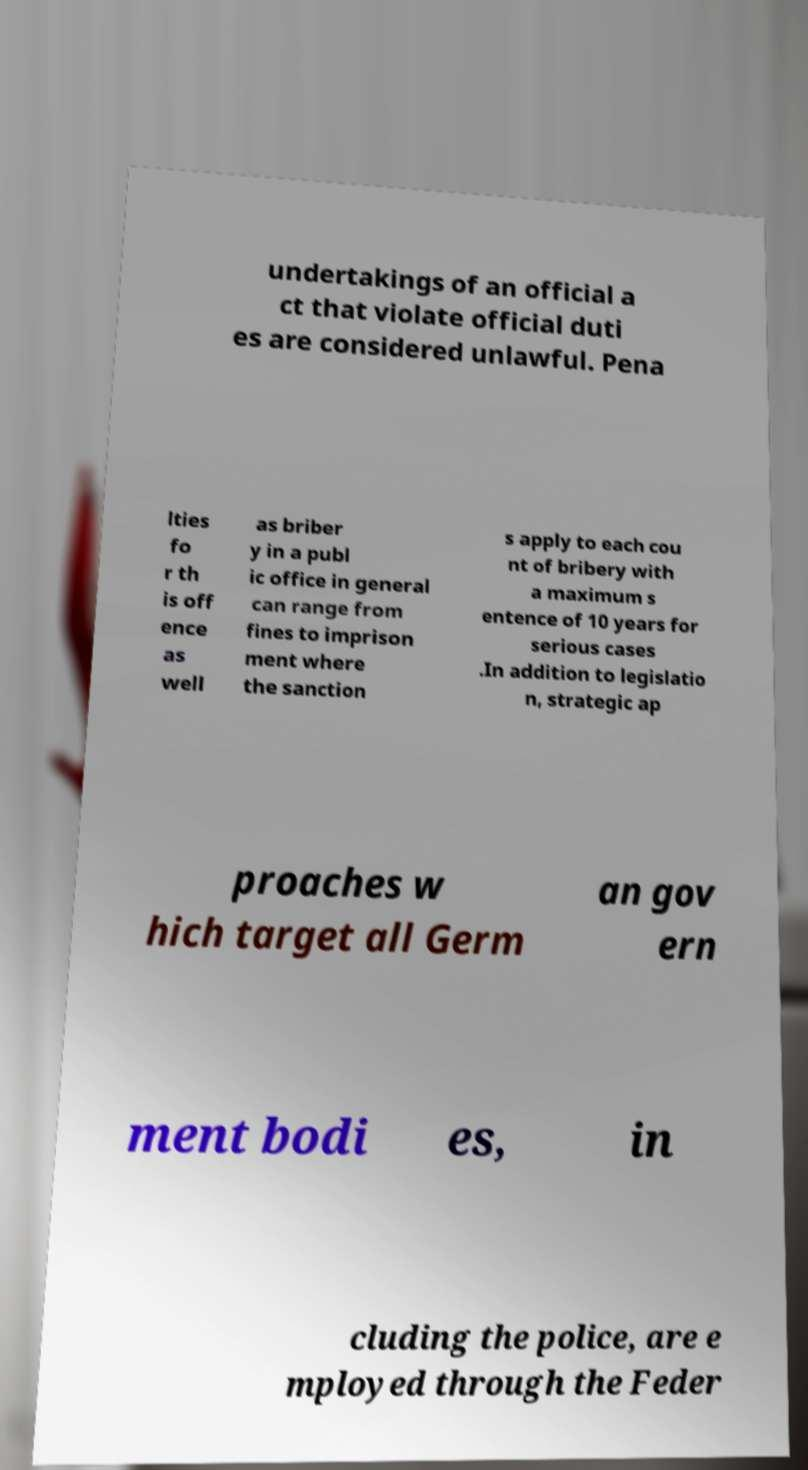What messages or text are displayed in this image? I need them in a readable, typed format. undertakings of an official a ct that violate official duti es are considered unlawful. Pena lties fo r th is off ence as well as briber y in a publ ic office in general can range from fines to imprison ment where the sanction s apply to each cou nt of bribery with a maximum s entence of 10 years for serious cases .In addition to legislatio n, strategic ap proaches w hich target all Germ an gov ern ment bodi es, in cluding the police, are e mployed through the Feder 